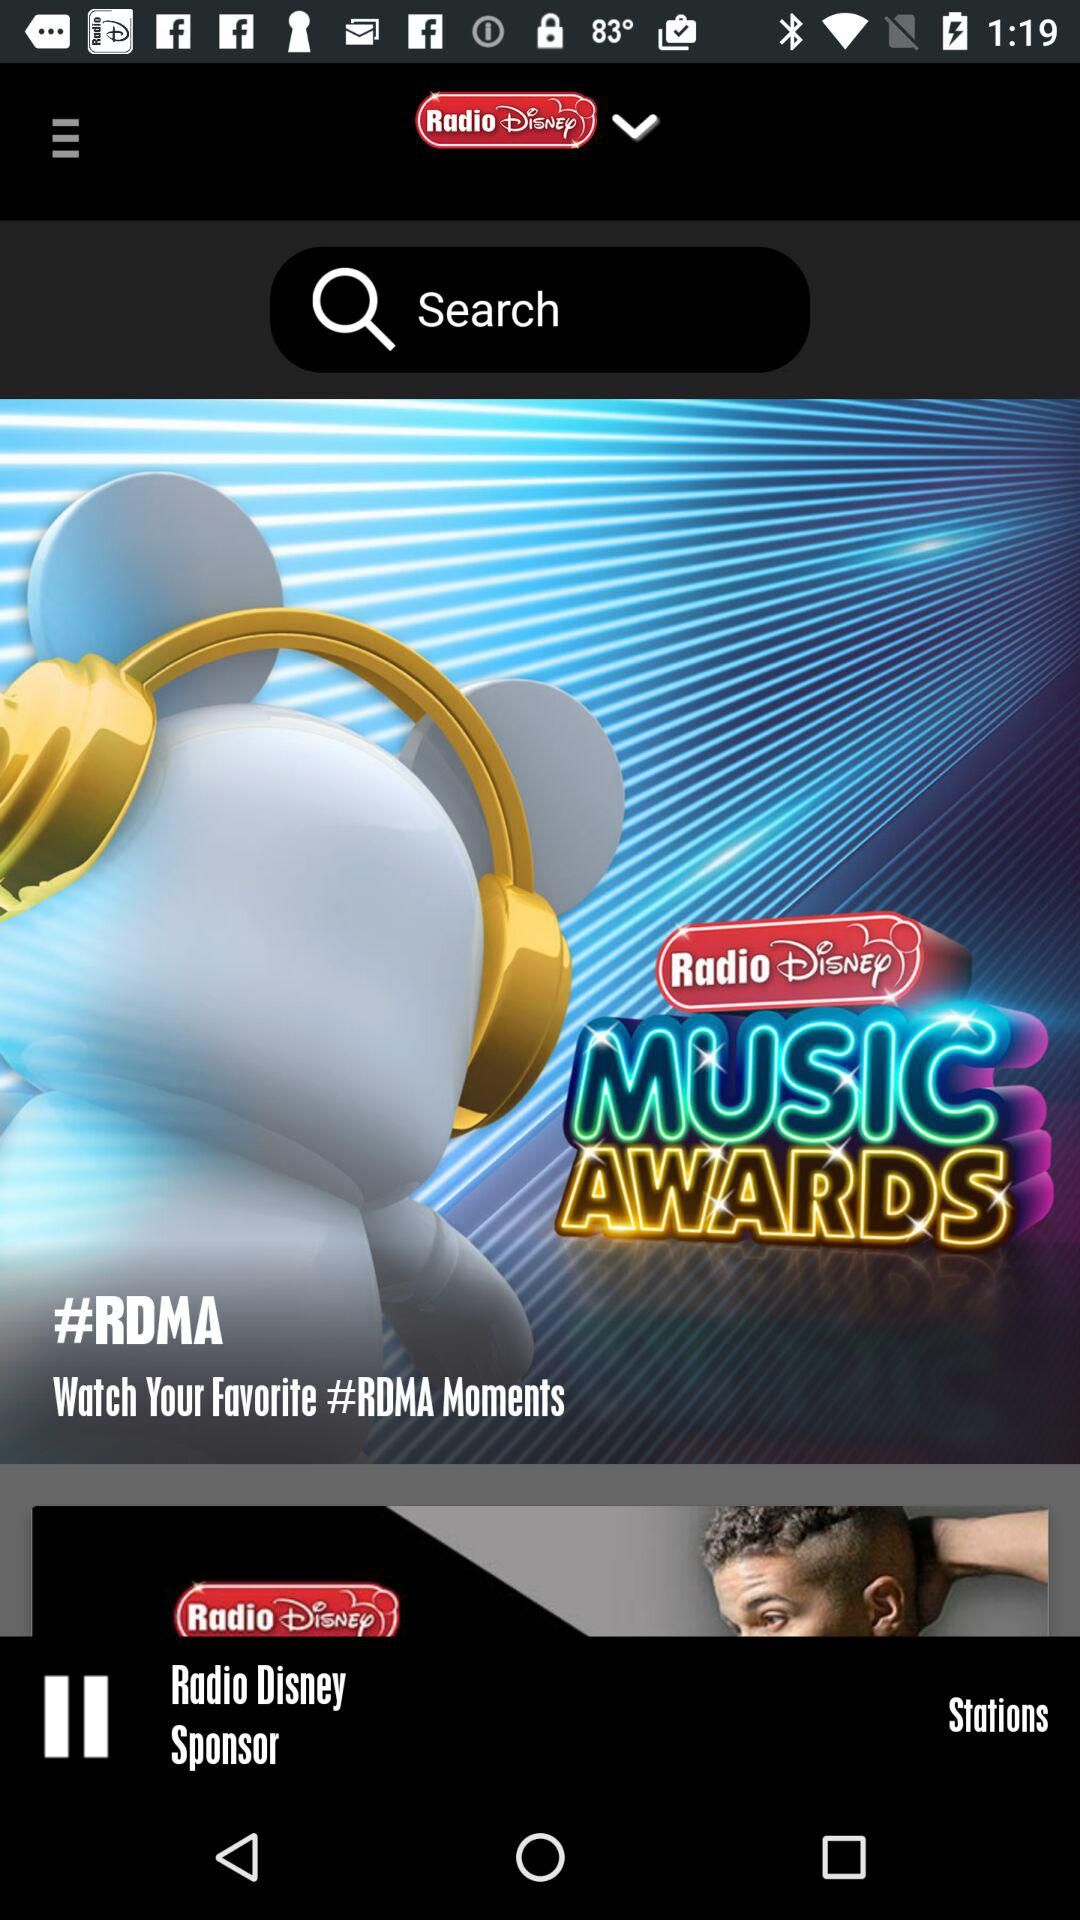What is the name of the application? The name of the application is "Radio Disney". 